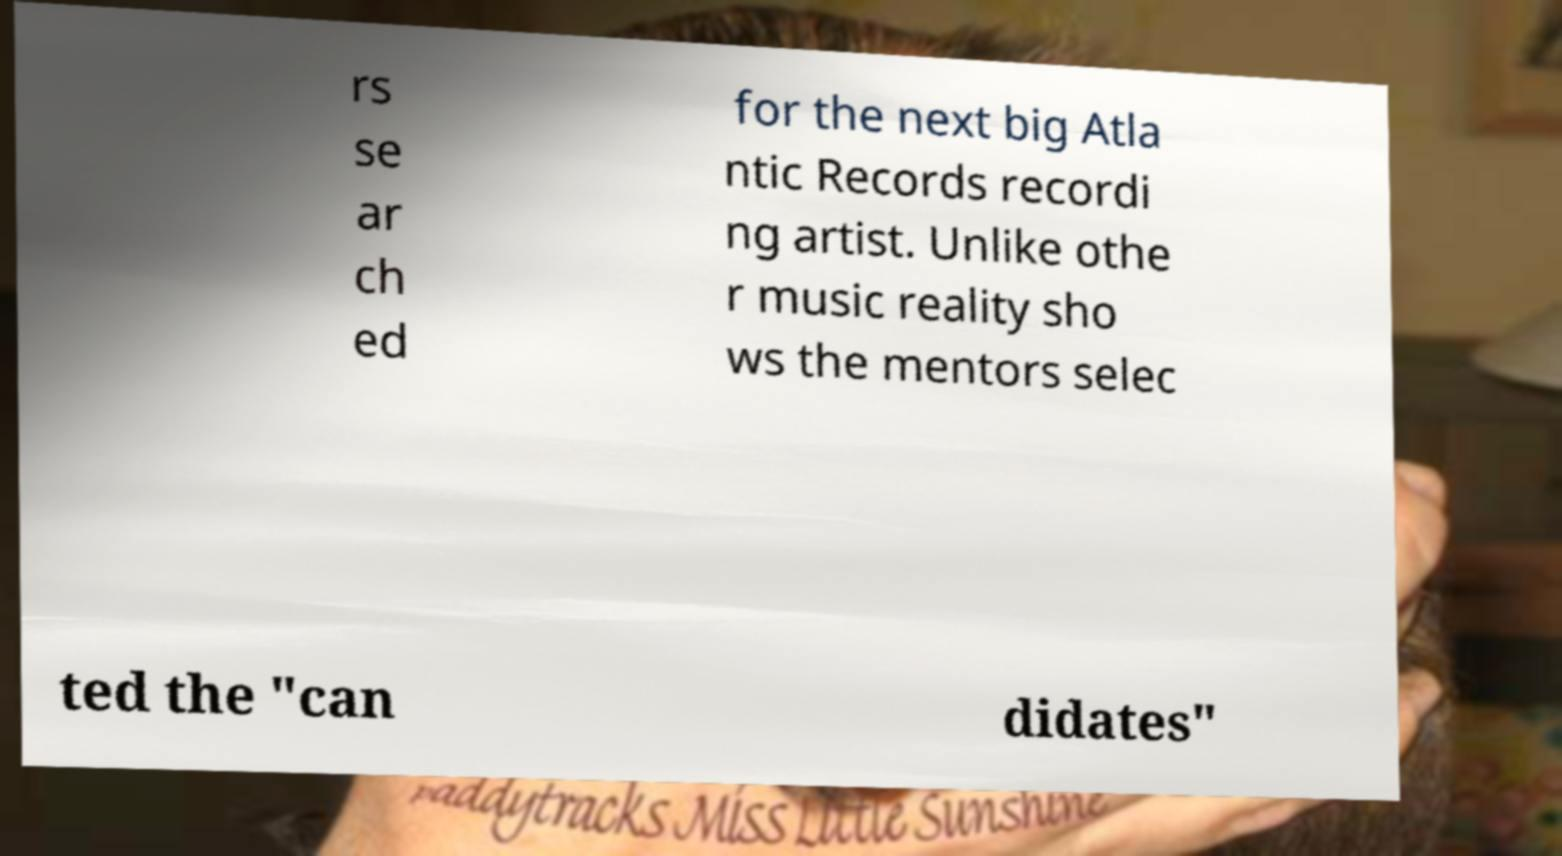What messages or text are displayed in this image? I need them in a readable, typed format. rs se ar ch ed for the next big Atla ntic Records recordi ng artist. Unlike othe r music reality sho ws the mentors selec ted the "can didates" 